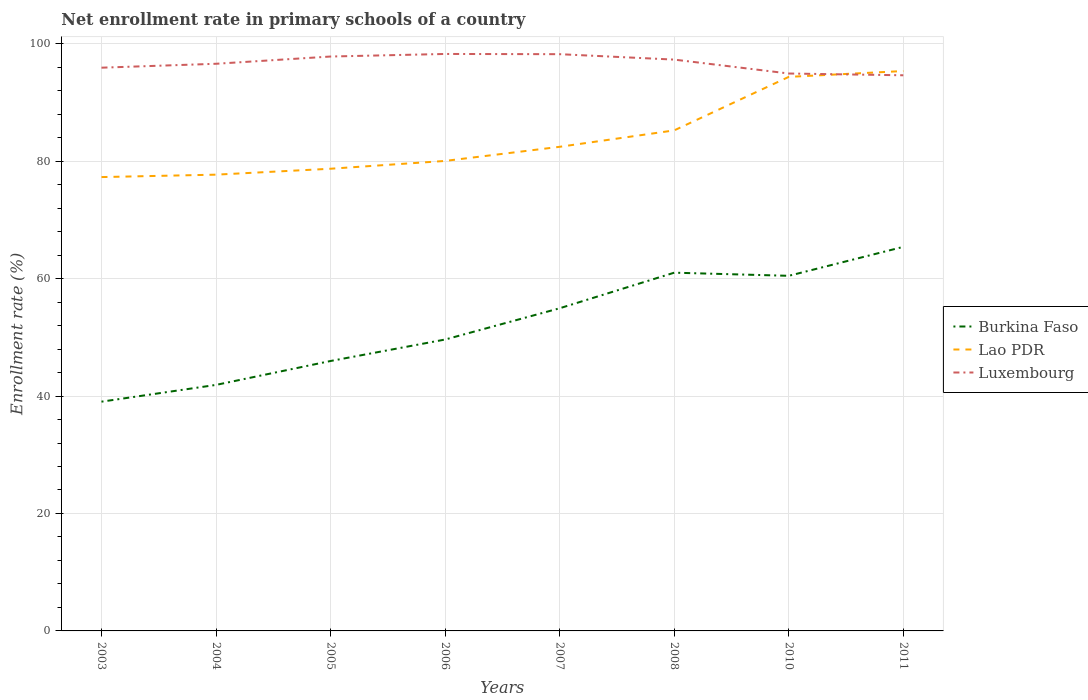Is the number of lines equal to the number of legend labels?
Your answer should be very brief. Yes. Across all years, what is the maximum enrollment rate in primary schools in Lao PDR?
Your answer should be very brief. 77.29. In which year was the enrollment rate in primary schools in Luxembourg maximum?
Offer a very short reply. 2011. What is the total enrollment rate in primary schools in Burkina Faso in the graph?
Your response must be concise. -18.58. What is the difference between the highest and the second highest enrollment rate in primary schools in Luxembourg?
Provide a succinct answer. 3.63. What is the difference between two consecutive major ticks on the Y-axis?
Offer a terse response. 20. Are the values on the major ticks of Y-axis written in scientific E-notation?
Offer a very short reply. No. Does the graph contain grids?
Offer a terse response. Yes. How are the legend labels stacked?
Your answer should be compact. Vertical. What is the title of the graph?
Make the answer very short. Net enrollment rate in primary schools of a country. Does "Macedonia" appear as one of the legend labels in the graph?
Your answer should be very brief. No. What is the label or title of the Y-axis?
Your answer should be compact. Enrollment rate (%). What is the Enrollment rate (%) in Burkina Faso in 2003?
Provide a short and direct response. 39.04. What is the Enrollment rate (%) in Lao PDR in 2003?
Keep it short and to the point. 77.29. What is the Enrollment rate (%) of Luxembourg in 2003?
Make the answer very short. 95.91. What is the Enrollment rate (%) of Burkina Faso in 2004?
Provide a succinct answer. 41.9. What is the Enrollment rate (%) of Lao PDR in 2004?
Offer a very short reply. 77.7. What is the Enrollment rate (%) of Luxembourg in 2004?
Ensure brevity in your answer.  96.58. What is the Enrollment rate (%) of Burkina Faso in 2005?
Offer a terse response. 45.97. What is the Enrollment rate (%) in Lao PDR in 2005?
Give a very brief answer. 78.71. What is the Enrollment rate (%) in Luxembourg in 2005?
Make the answer very short. 97.82. What is the Enrollment rate (%) in Burkina Faso in 2006?
Ensure brevity in your answer.  49.62. What is the Enrollment rate (%) in Lao PDR in 2006?
Make the answer very short. 80.04. What is the Enrollment rate (%) in Luxembourg in 2006?
Provide a succinct answer. 98.25. What is the Enrollment rate (%) in Burkina Faso in 2007?
Keep it short and to the point. 54.95. What is the Enrollment rate (%) in Lao PDR in 2007?
Keep it short and to the point. 82.44. What is the Enrollment rate (%) in Luxembourg in 2007?
Your response must be concise. 98.21. What is the Enrollment rate (%) in Burkina Faso in 2008?
Give a very brief answer. 61.01. What is the Enrollment rate (%) of Lao PDR in 2008?
Provide a short and direct response. 85.24. What is the Enrollment rate (%) of Luxembourg in 2008?
Give a very brief answer. 97.29. What is the Enrollment rate (%) in Burkina Faso in 2010?
Provide a short and direct response. 60.47. What is the Enrollment rate (%) of Lao PDR in 2010?
Your answer should be compact. 94.35. What is the Enrollment rate (%) in Luxembourg in 2010?
Ensure brevity in your answer.  94.92. What is the Enrollment rate (%) in Burkina Faso in 2011?
Your answer should be very brief. 65.4. What is the Enrollment rate (%) of Lao PDR in 2011?
Your answer should be very brief. 95.35. What is the Enrollment rate (%) in Luxembourg in 2011?
Keep it short and to the point. 94.62. Across all years, what is the maximum Enrollment rate (%) of Burkina Faso?
Offer a terse response. 65.4. Across all years, what is the maximum Enrollment rate (%) of Lao PDR?
Offer a very short reply. 95.35. Across all years, what is the maximum Enrollment rate (%) in Luxembourg?
Your answer should be very brief. 98.25. Across all years, what is the minimum Enrollment rate (%) in Burkina Faso?
Offer a very short reply. 39.04. Across all years, what is the minimum Enrollment rate (%) of Lao PDR?
Your answer should be very brief. 77.29. Across all years, what is the minimum Enrollment rate (%) of Luxembourg?
Offer a very short reply. 94.62. What is the total Enrollment rate (%) in Burkina Faso in the graph?
Make the answer very short. 418.36. What is the total Enrollment rate (%) of Lao PDR in the graph?
Your answer should be very brief. 671.11. What is the total Enrollment rate (%) in Luxembourg in the graph?
Your answer should be compact. 773.62. What is the difference between the Enrollment rate (%) in Burkina Faso in 2003 and that in 2004?
Provide a succinct answer. -2.86. What is the difference between the Enrollment rate (%) of Lao PDR in 2003 and that in 2004?
Keep it short and to the point. -0.41. What is the difference between the Enrollment rate (%) of Luxembourg in 2003 and that in 2004?
Make the answer very short. -0.67. What is the difference between the Enrollment rate (%) in Burkina Faso in 2003 and that in 2005?
Make the answer very short. -6.93. What is the difference between the Enrollment rate (%) of Lao PDR in 2003 and that in 2005?
Your answer should be compact. -1.42. What is the difference between the Enrollment rate (%) of Luxembourg in 2003 and that in 2005?
Provide a short and direct response. -1.9. What is the difference between the Enrollment rate (%) in Burkina Faso in 2003 and that in 2006?
Keep it short and to the point. -10.58. What is the difference between the Enrollment rate (%) in Lao PDR in 2003 and that in 2006?
Offer a very short reply. -2.75. What is the difference between the Enrollment rate (%) of Luxembourg in 2003 and that in 2006?
Keep it short and to the point. -2.34. What is the difference between the Enrollment rate (%) in Burkina Faso in 2003 and that in 2007?
Offer a very short reply. -15.91. What is the difference between the Enrollment rate (%) of Lao PDR in 2003 and that in 2007?
Ensure brevity in your answer.  -5.16. What is the difference between the Enrollment rate (%) of Luxembourg in 2003 and that in 2007?
Your answer should be compact. -2.3. What is the difference between the Enrollment rate (%) in Burkina Faso in 2003 and that in 2008?
Offer a terse response. -21.96. What is the difference between the Enrollment rate (%) in Lao PDR in 2003 and that in 2008?
Provide a short and direct response. -7.95. What is the difference between the Enrollment rate (%) of Luxembourg in 2003 and that in 2008?
Your answer should be very brief. -1.38. What is the difference between the Enrollment rate (%) of Burkina Faso in 2003 and that in 2010?
Offer a very short reply. -21.43. What is the difference between the Enrollment rate (%) in Lao PDR in 2003 and that in 2010?
Your answer should be very brief. -17.06. What is the difference between the Enrollment rate (%) of Luxembourg in 2003 and that in 2010?
Offer a terse response. 0.99. What is the difference between the Enrollment rate (%) of Burkina Faso in 2003 and that in 2011?
Offer a terse response. -26.36. What is the difference between the Enrollment rate (%) of Lao PDR in 2003 and that in 2011?
Offer a very short reply. -18.06. What is the difference between the Enrollment rate (%) in Luxembourg in 2003 and that in 2011?
Your answer should be very brief. 1.29. What is the difference between the Enrollment rate (%) in Burkina Faso in 2004 and that in 2005?
Provide a succinct answer. -4.07. What is the difference between the Enrollment rate (%) of Lao PDR in 2004 and that in 2005?
Offer a very short reply. -1.01. What is the difference between the Enrollment rate (%) in Luxembourg in 2004 and that in 2005?
Keep it short and to the point. -1.23. What is the difference between the Enrollment rate (%) of Burkina Faso in 2004 and that in 2006?
Make the answer very short. -7.73. What is the difference between the Enrollment rate (%) of Lao PDR in 2004 and that in 2006?
Ensure brevity in your answer.  -2.34. What is the difference between the Enrollment rate (%) in Luxembourg in 2004 and that in 2006?
Give a very brief answer. -1.67. What is the difference between the Enrollment rate (%) in Burkina Faso in 2004 and that in 2007?
Offer a terse response. -13.05. What is the difference between the Enrollment rate (%) in Lao PDR in 2004 and that in 2007?
Provide a short and direct response. -4.74. What is the difference between the Enrollment rate (%) in Luxembourg in 2004 and that in 2007?
Ensure brevity in your answer.  -1.63. What is the difference between the Enrollment rate (%) of Burkina Faso in 2004 and that in 2008?
Provide a short and direct response. -19.11. What is the difference between the Enrollment rate (%) in Lao PDR in 2004 and that in 2008?
Keep it short and to the point. -7.54. What is the difference between the Enrollment rate (%) of Luxembourg in 2004 and that in 2008?
Offer a terse response. -0.71. What is the difference between the Enrollment rate (%) of Burkina Faso in 2004 and that in 2010?
Offer a very short reply. -18.58. What is the difference between the Enrollment rate (%) of Lao PDR in 2004 and that in 2010?
Offer a terse response. -16.65. What is the difference between the Enrollment rate (%) of Luxembourg in 2004 and that in 2010?
Keep it short and to the point. 1.66. What is the difference between the Enrollment rate (%) of Burkina Faso in 2004 and that in 2011?
Your response must be concise. -23.51. What is the difference between the Enrollment rate (%) in Lao PDR in 2004 and that in 2011?
Keep it short and to the point. -17.65. What is the difference between the Enrollment rate (%) in Luxembourg in 2004 and that in 2011?
Give a very brief answer. 1.96. What is the difference between the Enrollment rate (%) of Burkina Faso in 2005 and that in 2006?
Offer a terse response. -3.66. What is the difference between the Enrollment rate (%) in Lao PDR in 2005 and that in 2006?
Give a very brief answer. -1.33. What is the difference between the Enrollment rate (%) of Luxembourg in 2005 and that in 2006?
Keep it short and to the point. -0.44. What is the difference between the Enrollment rate (%) of Burkina Faso in 2005 and that in 2007?
Give a very brief answer. -8.98. What is the difference between the Enrollment rate (%) of Lao PDR in 2005 and that in 2007?
Offer a terse response. -3.73. What is the difference between the Enrollment rate (%) in Luxembourg in 2005 and that in 2007?
Provide a succinct answer. -0.4. What is the difference between the Enrollment rate (%) in Burkina Faso in 2005 and that in 2008?
Provide a short and direct response. -15.04. What is the difference between the Enrollment rate (%) of Lao PDR in 2005 and that in 2008?
Give a very brief answer. -6.53. What is the difference between the Enrollment rate (%) of Luxembourg in 2005 and that in 2008?
Give a very brief answer. 0.52. What is the difference between the Enrollment rate (%) of Burkina Faso in 2005 and that in 2010?
Your answer should be very brief. -14.51. What is the difference between the Enrollment rate (%) of Lao PDR in 2005 and that in 2010?
Offer a very short reply. -15.64. What is the difference between the Enrollment rate (%) of Luxembourg in 2005 and that in 2010?
Keep it short and to the point. 2.89. What is the difference between the Enrollment rate (%) of Burkina Faso in 2005 and that in 2011?
Your response must be concise. -19.44. What is the difference between the Enrollment rate (%) of Lao PDR in 2005 and that in 2011?
Your response must be concise. -16.64. What is the difference between the Enrollment rate (%) of Luxembourg in 2005 and that in 2011?
Make the answer very short. 3.19. What is the difference between the Enrollment rate (%) of Burkina Faso in 2006 and that in 2007?
Ensure brevity in your answer.  -5.32. What is the difference between the Enrollment rate (%) in Lao PDR in 2006 and that in 2007?
Ensure brevity in your answer.  -2.4. What is the difference between the Enrollment rate (%) in Luxembourg in 2006 and that in 2007?
Provide a succinct answer. 0.04. What is the difference between the Enrollment rate (%) of Burkina Faso in 2006 and that in 2008?
Offer a very short reply. -11.38. What is the difference between the Enrollment rate (%) of Lao PDR in 2006 and that in 2008?
Provide a short and direct response. -5.2. What is the difference between the Enrollment rate (%) in Luxembourg in 2006 and that in 2008?
Your answer should be compact. 0.96. What is the difference between the Enrollment rate (%) in Burkina Faso in 2006 and that in 2010?
Offer a very short reply. -10.85. What is the difference between the Enrollment rate (%) of Lao PDR in 2006 and that in 2010?
Provide a short and direct response. -14.31. What is the difference between the Enrollment rate (%) of Luxembourg in 2006 and that in 2010?
Provide a succinct answer. 3.33. What is the difference between the Enrollment rate (%) in Burkina Faso in 2006 and that in 2011?
Your response must be concise. -15.78. What is the difference between the Enrollment rate (%) in Lao PDR in 2006 and that in 2011?
Provide a short and direct response. -15.31. What is the difference between the Enrollment rate (%) of Luxembourg in 2006 and that in 2011?
Offer a terse response. 3.63. What is the difference between the Enrollment rate (%) of Burkina Faso in 2007 and that in 2008?
Your response must be concise. -6.06. What is the difference between the Enrollment rate (%) of Lao PDR in 2007 and that in 2008?
Provide a short and direct response. -2.8. What is the difference between the Enrollment rate (%) of Luxembourg in 2007 and that in 2008?
Your response must be concise. 0.92. What is the difference between the Enrollment rate (%) in Burkina Faso in 2007 and that in 2010?
Give a very brief answer. -5.53. What is the difference between the Enrollment rate (%) of Lao PDR in 2007 and that in 2010?
Make the answer very short. -11.91. What is the difference between the Enrollment rate (%) in Luxembourg in 2007 and that in 2010?
Provide a short and direct response. 3.29. What is the difference between the Enrollment rate (%) in Burkina Faso in 2007 and that in 2011?
Keep it short and to the point. -10.46. What is the difference between the Enrollment rate (%) of Lao PDR in 2007 and that in 2011?
Your answer should be very brief. -12.9. What is the difference between the Enrollment rate (%) in Luxembourg in 2007 and that in 2011?
Provide a succinct answer. 3.59. What is the difference between the Enrollment rate (%) in Burkina Faso in 2008 and that in 2010?
Your answer should be compact. 0.53. What is the difference between the Enrollment rate (%) in Lao PDR in 2008 and that in 2010?
Your answer should be compact. -9.11. What is the difference between the Enrollment rate (%) in Luxembourg in 2008 and that in 2010?
Keep it short and to the point. 2.37. What is the difference between the Enrollment rate (%) in Burkina Faso in 2008 and that in 2011?
Make the answer very short. -4.4. What is the difference between the Enrollment rate (%) of Lao PDR in 2008 and that in 2011?
Your response must be concise. -10.11. What is the difference between the Enrollment rate (%) of Luxembourg in 2008 and that in 2011?
Your answer should be compact. 2.67. What is the difference between the Enrollment rate (%) in Burkina Faso in 2010 and that in 2011?
Make the answer very short. -4.93. What is the difference between the Enrollment rate (%) of Lao PDR in 2010 and that in 2011?
Offer a terse response. -1. What is the difference between the Enrollment rate (%) of Luxembourg in 2010 and that in 2011?
Your answer should be very brief. 0.3. What is the difference between the Enrollment rate (%) in Burkina Faso in 2003 and the Enrollment rate (%) in Lao PDR in 2004?
Provide a short and direct response. -38.66. What is the difference between the Enrollment rate (%) of Burkina Faso in 2003 and the Enrollment rate (%) of Luxembourg in 2004?
Give a very brief answer. -57.54. What is the difference between the Enrollment rate (%) of Lao PDR in 2003 and the Enrollment rate (%) of Luxembourg in 2004?
Your answer should be compact. -19.3. What is the difference between the Enrollment rate (%) in Burkina Faso in 2003 and the Enrollment rate (%) in Lao PDR in 2005?
Keep it short and to the point. -39.67. What is the difference between the Enrollment rate (%) in Burkina Faso in 2003 and the Enrollment rate (%) in Luxembourg in 2005?
Provide a succinct answer. -58.78. What is the difference between the Enrollment rate (%) in Lao PDR in 2003 and the Enrollment rate (%) in Luxembourg in 2005?
Provide a succinct answer. -20.53. What is the difference between the Enrollment rate (%) of Burkina Faso in 2003 and the Enrollment rate (%) of Lao PDR in 2006?
Keep it short and to the point. -41. What is the difference between the Enrollment rate (%) in Burkina Faso in 2003 and the Enrollment rate (%) in Luxembourg in 2006?
Keep it short and to the point. -59.21. What is the difference between the Enrollment rate (%) of Lao PDR in 2003 and the Enrollment rate (%) of Luxembourg in 2006?
Your response must be concise. -20.97. What is the difference between the Enrollment rate (%) in Burkina Faso in 2003 and the Enrollment rate (%) in Lao PDR in 2007?
Your answer should be very brief. -43.4. What is the difference between the Enrollment rate (%) in Burkina Faso in 2003 and the Enrollment rate (%) in Luxembourg in 2007?
Provide a short and direct response. -59.17. What is the difference between the Enrollment rate (%) in Lao PDR in 2003 and the Enrollment rate (%) in Luxembourg in 2007?
Provide a succinct answer. -20.93. What is the difference between the Enrollment rate (%) in Burkina Faso in 2003 and the Enrollment rate (%) in Lao PDR in 2008?
Make the answer very short. -46.2. What is the difference between the Enrollment rate (%) in Burkina Faso in 2003 and the Enrollment rate (%) in Luxembourg in 2008?
Provide a succinct answer. -58.25. What is the difference between the Enrollment rate (%) in Lao PDR in 2003 and the Enrollment rate (%) in Luxembourg in 2008?
Offer a very short reply. -20.01. What is the difference between the Enrollment rate (%) of Burkina Faso in 2003 and the Enrollment rate (%) of Lao PDR in 2010?
Provide a succinct answer. -55.31. What is the difference between the Enrollment rate (%) in Burkina Faso in 2003 and the Enrollment rate (%) in Luxembourg in 2010?
Offer a very short reply. -55.88. What is the difference between the Enrollment rate (%) of Lao PDR in 2003 and the Enrollment rate (%) of Luxembourg in 2010?
Your answer should be compact. -17.64. What is the difference between the Enrollment rate (%) of Burkina Faso in 2003 and the Enrollment rate (%) of Lao PDR in 2011?
Offer a very short reply. -56.3. What is the difference between the Enrollment rate (%) of Burkina Faso in 2003 and the Enrollment rate (%) of Luxembourg in 2011?
Offer a terse response. -55.58. What is the difference between the Enrollment rate (%) in Lao PDR in 2003 and the Enrollment rate (%) in Luxembourg in 2011?
Your answer should be very brief. -17.34. What is the difference between the Enrollment rate (%) of Burkina Faso in 2004 and the Enrollment rate (%) of Lao PDR in 2005?
Your response must be concise. -36.81. What is the difference between the Enrollment rate (%) in Burkina Faso in 2004 and the Enrollment rate (%) in Luxembourg in 2005?
Your answer should be compact. -55.92. What is the difference between the Enrollment rate (%) in Lao PDR in 2004 and the Enrollment rate (%) in Luxembourg in 2005?
Your answer should be very brief. -20.12. What is the difference between the Enrollment rate (%) of Burkina Faso in 2004 and the Enrollment rate (%) of Lao PDR in 2006?
Offer a very short reply. -38.14. What is the difference between the Enrollment rate (%) of Burkina Faso in 2004 and the Enrollment rate (%) of Luxembourg in 2006?
Your answer should be very brief. -56.36. What is the difference between the Enrollment rate (%) in Lao PDR in 2004 and the Enrollment rate (%) in Luxembourg in 2006?
Provide a short and direct response. -20.55. What is the difference between the Enrollment rate (%) of Burkina Faso in 2004 and the Enrollment rate (%) of Lao PDR in 2007?
Give a very brief answer. -40.55. What is the difference between the Enrollment rate (%) in Burkina Faso in 2004 and the Enrollment rate (%) in Luxembourg in 2007?
Offer a terse response. -56.32. What is the difference between the Enrollment rate (%) in Lao PDR in 2004 and the Enrollment rate (%) in Luxembourg in 2007?
Give a very brief answer. -20.52. What is the difference between the Enrollment rate (%) of Burkina Faso in 2004 and the Enrollment rate (%) of Lao PDR in 2008?
Ensure brevity in your answer.  -43.34. What is the difference between the Enrollment rate (%) in Burkina Faso in 2004 and the Enrollment rate (%) in Luxembourg in 2008?
Your response must be concise. -55.4. What is the difference between the Enrollment rate (%) in Lao PDR in 2004 and the Enrollment rate (%) in Luxembourg in 2008?
Make the answer very short. -19.59. What is the difference between the Enrollment rate (%) in Burkina Faso in 2004 and the Enrollment rate (%) in Lao PDR in 2010?
Provide a short and direct response. -52.45. What is the difference between the Enrollment rate (%) in Burkina Faso in 2004 and the Enrollment rate (%) in Luxembourg in 2010?
Offer a very short reply. -53.03. What is the difference between the Enrollment rate (%) of Lao PDR in 2004 and the Enrollment rate (%) of Luxembourg in 2010?
Offer a terse response. -17.22. What is the difference between the Enrollment rate (%) of Burkina Faso in 2004 and the Enrollment rate (%) of Lao PDR in 2011?
Provide a short and direct response. -53.45. What is the difference between the Enrollment rate (%) in Burkina Faso in 2004 and the Enrollment rate (%) in Luxembourg in 2011?
Provide a short and direct response. -52.73. What is the difference between the Enrollment rate (%) in Lao PDR in 2004 and the Enrollment rate (%) in Luxembourg in 2011?
Provide a short and direct response. -16.92. What is the difference between the Enrollment rate (%) of Burkina Faso in 2005 and the Enrollment rate (%) of Lao PDR in 2006?
Your answer should be compact. -34.07. What is the difference between the Enrollment rate (%) in Burkina Faso in 2005 and the Enrollment rate (%) in Luxembourg in 2006?
Keep it short and to the point. -52.29. What is the difference between the Enrollment rate (%) in Lao PDR in 2005 and the Enrollment rate (%) in Luxembourg in 2006?
Your answer should be compact. -19.55. What is the difference between the Enrollment rate (%) of Burkina Faso in 2005 and the Enrollment rate (%) of Lao PDR in 2007?
Provide a short and direct response. -36.47. What is the difference between the Enrollment rate (%) in Burkina Faso in 2005 and the Enrollment rate (%) in Luxembourg in 2007?
Your answer should be compact. -52.25. What is the difference between the Enrollment rate (%) of Lao PDR in 2005 and the Enrollment rate (%) of Luxembourg in 2007?
Ensure brevity in your answer.  -19.51. What is the difference between the Enrollment rate (%) of Burkina Faso in 2005 and the Enrollment rate (%) of Lao PDR in 2008?
Your response must be concise. -39.27. What is the difference between the Enrollment rate (%) of Burkina Faso in 2005 and the Enrollment rate (%) of Luxembourg in 2008?
Your response must be concise. -51.33. What is the difference between the Enrollment rate (%) in Lao PDR in 2005 and the Enrollment rate (%) in Luxembourg in 2008?
Ensure brevity in your answer.  -18.59. What is the difference between the Enrollment rate (%) in Burkina Faso in 2005 and the Enrollment rate (%) in Lao PDR in 2010?
Make the answer very short. -48.38. What is the difference between the Enrollment rate (%) of Burkina Faso in 2005 and the Enrollment rate (%) of Luxembourg in 2010?
Keep it short and to the point. -48.96. What is the difference between the Enrollment rate (%) of Lao PDR in 2005 and the Enrollment rate (%) of Luxembourg in 2010?
Provide a short and direct response. -16.22. What is the difference between the Enrollment rate (%) of Burkina Faso in 2005 and the Enrollment rate (%) of Lao PDR in 2011?
Keep it short and to the point. -49.38. What is the difference between the Enrollment rate (%) in Burkina Faso in 2005 and the Enrollment rate (%) in Luxembourg in 2011?
Ensure brevity in your answer.  -48.65. What is the difference between the Enrollment rate (%) in Lao PDR in 2005 and the Enrollment rate (%) in Luxembourg in 2011?
Give a very brief answer. -15.91. What is the difference between the Enrollment rate (%) in Burkina Faso in 2006 and the Enrollment rate (%) in Lao PDR in 2007?
Your answer should be very brief. -32.82. What is the difference between the Enrollment rate (%) of Burkina Faso in 2006 and the Enrollment rate (%) of Luxembourg in 2007?
Offer a terse response. -48.59. What is the difference between the Enrollment rate (%) of Lao PDR in 2006 and the Enrollment rate (%) of Luxembourg in 2007?
Offer a very short reply. -18.18. What is the difference between the Enrollment rate (%) in Burkina Faso in 2006 and the Enrollment rate (%) in Lao PDR in 2008?
Offer a terse response. -35.62. What is the difference between the Enrollment rate (%) in Burkina Faso in 2006 and the Enrollment rate (%) in Luxembourg in 2008?
Provide a short and direct response. -47.67. What is the difference between the Enrollment rate (%) of Lao PDR in 2006 and the Enrollment rate (%) of Luxembourg in 2008?
Give a very brief answer. -17.26. What is the difference between the Enrollment rate (%) of Burkina Faso in 2006 and the Enrollment rate (%) of Lao PDR in 2010?
Make the answer very short. -44.73. What is the difference between the Enrollment rate (%) of Burkina Faso in 2006 and the Enrollment rate (%) of Luxembourg in 2010?
Your answer should be compact. -45.3. What is the difference between the Enrollment rate (%) of Lao PDR in 2006 and the Enrollment rate (%) of Luxembourg in 2010?
Your answer should be very brief. -14.89. What is the difference between the Enrollment rate (%) of Burkina Faso in 2006 and the Enrollment rate (%) of Lao PDR in 2011?
Keep it short and to the point. -45.72. What is the difference between the Enrollment rate (%) in Burkina Faso in 2006 and the Enrollment rate (%) in Luxembourg in 2011?
Offer a very short reply. -45. What is the difference between the Enrollment rate (%) in Lao PDR in 2006 and the Enrollment rate (%) in Luxembourg in 2011?
Ensure brevity in your answer.  -14.58. What is the difference between the Enrollment rate (%) in Burkina Faso in 2007 and the Enrollment rate (%) in Lao PDR in 2008?
Keep it short and to the point. -30.29. What is the difference between the Enrollment rate (%) in Burkina Faso in 2007 and the Enrollment rate (%) in Luxembourg in 2008?
Offer a terse response. -42.35. What is the difference between the Enrollment rate (%) in Lao PDR in 2007 and the Enrollment rate (%) in Luxembourg in 2008?
Your response must be concise. -14.85. What is the difference between the Enrollment rate (%) in Burkina Faso in 2007 and the Enrollment rate (%) in Lao PDR in 2010?
Offer a very short reply. -39.4. What is the difference between the Enrollment rate (%) in Burkina Faso in 2007 and the Enrollment rate (%) in Luxembourg in 2010?
Give a very brief answer. -39.98. What is the difference between the Enrollment rate (%) of Lao PDR in 2007 and the Enrollment rate (%) of Luxembourg in 2010?
Keep it short and to the point. -12.48. What is the difference between the Enrollment rate (%) of Burkina Faso in 2007 and the Enrollment rate (%) of Lao PDR in 2011?
Your response must be concise. -40.4. What is the difference between the Enrollment rate (%) of Burkina Faso in 2007 and the Enrollment rate (%) of Luxembourg in 2011?
Your answer should be compact. -39.68. What is the difference between the Enrollment rate (%) in Lao PDR in 2007 and the Enrollment rate (%) in Luxembourg in 2011?
Your answer should be compact. -12.18. What is the difference between the Enrollment rate (%) of Burkina Faso in 2008 and the Enrollment rate (%) of Lao PDR in 2010?
Your answer should be compact. -33.34. What is the difference between the Enrollment rate (%) in Burkina Faso in 2008 and the Enrollment rate (%) in Luxembourg in 2010?
Provide a short and direct response. -33.92. What is the difference between the Enrollment rate (%) in Lao PDR in 2008 and the Enrollment rate (%) in Luxembourg in 2010?
Your answer should be compact. -9.68. What is the difference between the Enrollment rate (%) in Burkina Faso in 2008 and the Enrollment rate (%) in Lao PDR in 2011?
Give a very brief answer. -34.34. What is the difference between the Enrollment rate (%) in Burkina Faso in 2008 and the Enrollment rate (%) in Luxembourg in 2011?
Your response must be concise. -33.62. What is the difference between the Enrollment rate (%) of Lao PDR in 2008 and the Enrollment rate (%) of Luxembourg in 2011?
Offer a very short reply. -9.38. What is the difference between the Enrollment rate (%) in Burkina Faso in 2010 and the Enrollment rate (%) in Lao PDR in 2011?
Make the answer very short. -34.87. What is the difference between the Enrollment rate (%) of Burkina Faso in 2010 and the Enrollment rate (%) of Luxembourg in 2011?
Ensure brevity in your answer.  -34.15. What is the difference between the Enrollment rate (%) of Lao PDR in 2010 and the Enrollment rate (%) of Luxembourg in 2011?
Your response must be concise. -0.27. What is the average Enrollment rate (%) in Burkina Faso per year?
Provide a short and direct response. 52.29. What is the average Enrollment rate (%) in Lao PDR per year?
Make the answer very short. 83.89. What is the average Enrollment rate (%) of Luxembourg per year?
Offer a very short reply. 96.7. In the year 2003, what is the difference between the Enrollment rate (%) in Burkina Faso and Enrollment rate (%) in Lao PDR?
Make the answer very short. -38.24. In the year 2003, what is the difference between the Enrollment rate (%) of Burkina Faso and Enrollment rate (%) of Luxembourg?
Make the answer very short. -56.87. In the year 2003, what is the difference between the Enrollment rate (%) of Lao PDR and Enrollment rate (%) of Luxembourg?
Give a very brief answer. -18.63. In the year 2004, what is the difference between the Enrollment rate (%) in Burkina Faso and Enrollment rate (%) in Lao PDR?
Your answer should be very brief. -35.8. In the year 2004, what is the difference between the Enrollment rate (%) in Burkina Faso and Enrollment rate (%) in Luxembourg?
Ensure brevity in your answer.  -54.69. In the year 2004, what is the difference between the Enrollment rate (%) of Lao PDR and Enrollment rate (%) of Luxembourg?
Your answer should be very brief. -18.88. In the year 2005, what is the difference between the Enrollment rate (%) in Burkina Faso and Enrollment rate (%) in Lao PDR?
Give a very brief answer. -32.74. In the year 2005, what is the difference between the Enrollment rate (%) in Burkina Faso and Enrollment rate (%) in Luxembourg?
Your answer should be compact. -51.85. In the year 2005, what is the difference between the Enrollment rate (%) of Lao PDR and Enrollment rate (%) of Luxembourg?
Your answer should be compact. -19.11. In the year 2006, what is the difference between the Enrollment rate (%) in Burkina Faso and Enrollment rate (%) in Lao PDR?
Make the answer very short. -30.41. In the year 2006, what is the difference between the Enrollment rate (%) in Burkina Faso and Enrollment rate (%) in Luxembourg?
Your answer should be compact. -48.63. In the year 2006, what is the difference between the Enrollment rate (%) in Lao PDR and Enrollment rate (%) in Luxembourg?
Ensure brevity in your answer.  -18.22. In the year 2007, what is the difference between the Enrollment rate (%) in Burkina Faso and Enrollment rate (%) in Lao PDR?
Ensure brevity in your answer.  -27.5. In the year 2007, what is the difference between the Enrollment rate (%) of Burkina Faso and Enrollment rate (%) of Luxembourg?
Your response must be concise. -43.27. In the year 2007, what is the difference between the Enrollment rate (%) in Lao PDR and Enrollment rate (%) in Luxembourg?
Make the answer very short. -15.77. In the year 2008, what is the difference between the Enrollment rate (%) in Burkina Faso and Enrollment rate (%) in Lao PDR?
Your response must be concise. -24.23. In the year 2008, what is the difference between the Enrollment rate (%) in Burkina Faso and Enrollment rate (%) in Luxembourg?
Make the answer very short. -36.29. In the year 2008, what is the difference between the Enrollment rate (%) in Lao PDR and Enrollment rate (%) in Luxembourg?
Provide a short and direct response. -12.05. In the year 2010, what is the difference between the Enrollment rate (%) in Burkina Faso and Enrollment rate (%) in Lao PDR?
Keep it short and to the point. -33.88. In the year 2010, what is the difference between the Enrollment rate (%) of Burkina Faso and Enrollment rate (%) of Luxembourg?
Your answer should be compact. -34.45. In the year 2010, what is the difference between the Enrollment rate (%) of Lao PDR and Enrollment rate (%) of Luxembourg?
Provide a short and direct response. -0.57. In the year 2011, what is the difference between the Enrollment rate (%) of Burkina Faso and Enrollment rate (%) of Lao PDR?
Ensure brevity in your answer.  -29.94. In the year 2011, what is the difference between the Enrollment rate (%) of Burkina Faso and Enrollment rate (%) of Luxembourg?
Provide a short and direct response. -29.22. In the year 2011, what is the difference between the Enrollment rate (%) of Lao PDR and Enrollment rate (%) of Luxembourg?
Ensure brevity in your answer.  0.72. What is the ratio of the Enrollment rate (%) of Burkina Faso in 2003 to that in 2004?
Your answer should be very brief. 0.93. What is the ratio of the Enrollment rate (%) of Burkina Faso in 2003 to that in 2005?
Make the answer very short. 0.85. What is the ratio of the Enrollment rate (%) in Lao PDR in 2003 to that in 2005?
Provide a succinct answer. 0.98. What is the ratio of the Enrollment rate (%) in Luxembourg in 2003 to that in 2005?
Your answer should be compact. 0.98. What is the ratio of the Enrollment rate (%) of Burkina Faso in 2003 to that in 2006?
Your answer should be compact. 0.79. What is the ratio of the Enrollment rate (%) of Lao PDR in 2003 to that in 2006?
Offer a very short reply. 0.97. What is the ratio of the Enrollment rate (%) in Luxembourg in 2003 to that in 2006?
Your response must be concise. 0.98. What is the ratio of the Enrollment rate (%) of Burkina Faso in 2003 to that in 2007?
Provide a succinct answer. 0.71. What is the ratio of the Enrollment rate (%) of Luxembourg in 2003 to that in 2007?
Ensure brevity in your answer.  0.98. What is the ratio of the Enrollment rate (%) in Burkina Faso in 2003 to that in 2008?
Your answer should be compact. 0.64. What is the ratio of the Enrollment rate (%) of Lao PDR in 2003 to that in 2008?
Give a very brief answer. 0.91. What is the ratio of the Enrollment rate (%) of Luxembourg in 2003 to that in 2008?
Keep it short and to the point. 0.99. What is the ratio of the Enrollment rate (%) of Burkina Faso in 2003 to that in 2010?
Offer a very short reply. 0.65. What is the ratio of the Enrollment rate (%) in Lao PDR in 2003 to that in 2010?
Offer a very short reply. 0.82. What is the ratio of the Enrollment rate (%) in Luxembourg in 2003 to that in 2010?
Provide a short and direct response. 1.01. What is the ratio of the Enrollment rate (%) in Burkina Faso in 2003 to that in 2011?
Your response must be concise. 0.6. What is the ratio of the Enrollment rate (%) of Lao PDR in 2003 to that in 2011?
Offer a terse response. 0.81. What is the ratio of the Enrollment rate (%) in Luxembourg in 2003 to that in 2011?
Provide a succinct answer. 1.01. What is the ratio of the Enrollment rate (%) of Burkina Faso in 2004 to that in 2005?
Offer a very short reply. 0.91. What is the ratio of the Enrollment rate (%) in Lao PDR in 2004 to that in 2005?
Your response must be concise. 0.99. What is the ratio of the Enrollment rate (%) of Luxembourg in 2004 to that in 2005?
Give a very brief answer. 0.99. What is the ratio of the Enrollment rate (%) of Burkina Faso in 2004 to that in 2006?
Give a very brief answer. 0.84. What is the ratio of the Enrollment rate (%) of Lao PDR in 2004 to that in 2006?
Provide a succinct answer. 0.97. What is the ratio of the Enrollment rate (%) of Luxembourg in 2004 to that in 2006?
Your answer should be very brief. 0.98. What is the ratio of the Enrollment rate (%) of Burkina Faso in 2004 to that in 2007?
Your answer should be compact. 0.76. What is the ratio of the Enrollment rate (%) in Lao PDR in 2004 to that in 2007?
Ensure brevity in your answer.  0.94. What is the ratio of the Enrollment rate (%) in Luxembourg in 2004 to that in 2007?
Provide a short and direct response. 0.98. What is the ratio of the Enrollment rate (%) in Burkina Faso in 2004 to that in 2008?
Offer a terse response. 0.69. What is the ratio of the Enrollment rate (%) of Lao PDR in 2004 to that in 2008?
Your answer should be very brief. 0.91. What is the ratio of the Enrollment rate (%) in Burkina Faso in 2004 to that in 2010?
Make the answer very short. 0.69. What is the ratio of the Enrollment rate (%) of Lao PDR in 2004 to that in 2010?
Your answer should be very brief. 0.82. What is the ratio of the Enrollment rate (%) in Luxembourg in 2004 to that in 2010?
Your answer should be compact. 1.02. What is the ratio of the Enrollment rate (%) in Burkina Faso in 2004 to that in 2011?
Provide a short and direct response. 0.64. What is the ratio of the Enrollment rate (%) of Lao PDR in 2004 to that in 2011?
Ensure brevity in your answer.  0.81. What is the ratio of the Enrollment rate (%) of Luxembourg in 2004 to that in 2011?
Your answer should be very brief. 1.02. What is the ratio of the Enrollment rate (%) of Burkina Faso in 2005 to that in 2006?
Offer a very short reply. 0.93. What is the ratio of the Enrollment rate (%) in Lao PDR in 2005 to that in 2006?
Your answer should be very brief. 0.98. What is the ratio of the Enrollment rate (%) of Luxembourg in 2005 to that in 2006?
Offer a terse response. 1. What is the ratio of the Enrollment rate (%) of Burkina Faso in 2005 to that in 2007?
Your answer should be compact. 0.84. What is the ratio of the Enrollment rate (%) in Lao PDR in 2005 to that in 2007?
Your answer should be compact. 0.95. What is the ratio of the Enrollment rate (%) of Burkina Faso in 2005 to that in 2008?
Your answer should be compact. 0.75. What is the ratio of the Enrollment rate (%) of Lao PDR in 2005 to that in 2008?
Provide a succinct answer. 0.92. What is the ratio of the Enrollment rate (%) of Luxembourg in 2005 to that in 2008?
Keep it short and to the point. 1.01. What is the ratio of the Enrollment rate (%) in Burkina Faso in 2005 to that in 2010?
Offer a very short reply. 0.76. What is the ratio of the Enrollment rate (%) in Lao PDR in 2005 to that in 2010?
Your answer should be very brief. 0.83. What is the ratio of the Enrollment rate (%) of Luxembourg in 2005 to that in 2010?
Make the answer very short. 1.03. What is the ratio of the Enrollment rate (%) of Burkina Faso in 2005 to that in 2011?
Offer a terse response. 0.7. What is the ratio of the Enrollment rate (%) in Lao PDR in 2005 to that in 2011?
Provide a short and direct response. 0.83. What is the ratio of the Enrollment rate (%) of Luxembourg in 2005 to that in 2011?
Offer a terse response. 1.03. What is the ratio of the Enrollment rate (%) in Burkina Faso in 2006 to that in 2007?
Keep it short and to the point. 0.9. What is the ratio of the Enrollment rate (%) in Lao PDR in 2006 to that in 2007?
Offer a very short reply. 0.97. What is the ratio of the Enrollment rate (%) in Burkina Faso in 2006 to that in 2008?
Your response must be concise. 0.81. What is the ratio of the Enrollment rate (%) of Lao PDR in 2006 to that in 2008?
Keep it short and to the point. 0.94. What is the ratio of the Enrollment rate (%) of Luxembourg in 2006 to that in 2008?
Keep it short and to the point. 1.01. What is the ratio of the Enrollment rate (%) in Burkina Faso in 2006 to that in 2010?
Provide a succinct answer. 0.82. What is the ratio of the Enrollment rate (%) in Lao PDR in 2006 to that in 2010?
Your answer should be very brief. 0.85. What is the ratio of the Enrollment rate (%) of Luxembourg in 2006 to that in 2010?
Make the answer very short. 1.04. What is the ratio of the Enrollment rate (%) of Burkina Faso in 2006 to that in 2011?
Your response must be concise. 0.76. What is the ratio of the Enrollment rate (%) in Lao PDR in 2006 to that in 2011?
Offer a terse response. 0.84. What is the ratio of the Enrollment rate (%) in Luxembourg in 2006 to that in 2011?
Offer a terse response. 1.04. What is the ratio of the Enrollment rate (%) of Burkina Faso in 2007 to that in 2008?
Give a very brief answer. 0.9. What is the ratio of the Enrollment rate (%) in Lao PDR in 2007 to that in 2008?
Provide a short and direct response. 0.97. What is the ratio of the Enrollment rate (%) of Luxembourg in 2007 to that in 2008?
Make the answer very short. 1.01. What is the ratio of the Enrollment rate (%) of Burkina Faso in 2007 to that in 2010?
Your answer should be compact. 0.91. What is the ratio of the Enrollment rate (%) of Lao PDR in 2007 to that in 2010?
Offer a terse response. 0.87. What is the ratio of the Enrollment rate (%) of Luxembourg in 2007 to that in 2010?
Offer a terse response. 1.03. What is the ratio of the Enrollment rate (%) in Burkina Faso in 2007 to that in 2011?
Ensure brevity in your answer.  0.84. What is the ratio of the Enrollment rate (%) in Lao PDR in 2007 to that in 2011?
Your response must be concise. 0.86. What is the ratio of the Enrollment rate (%) of Luxembourg in 2007 to that in 2011?
Make the answer very short. 1.04. What is the ratio of the Enrollment rate (%) of Burkina Faso in 2008 to that in 2010?
Your answer should be compact. 1.01. What is the ratio of the Enrollment rate (%) in Lao PDR in 2008 to that in 2010?
Your answer should be compact. 0.9. What is the ratio of the Enrollment rate (%) in Luxembourg in 2008 to that in 2010?
Give a very brief answer. 1.02. What is the ratio of the Enrollment rate (%) in Burkina Faso in 2008 to that in 2011?
Provide a succinct answer. 0.93. What is the ratio of the Enrollment rate (%) in Lao PDR in 2008 to that in 2011?
Give a very brief answer. 0.89. What is the ratio of the Enrollment rate (%) in Luxembourg in 2008 to that in 2011?
Your answer should be compact. 1.03. What is the ratio of the Enrollment rate (%) in Burkina Faso in 2010 to that in 2011?
Make the answer very short. 0.92. What is the difference between the highest and the second highest Enrollment rate (%) of Burkina Faso?
Provide a succinct answer. 4.4. What is the difference between the highest and the second highest Enrollment rate (%) in Luxembourg?
Keep it short and to the point. 0.04. What is the difference between the highest and the lowest Enrollment rate (%) in Burkina Faso?
Give a very brief answer. 26.36. What is the difference between the highest and the lowest Enrollment rate (%) of Lao PDR?
Ensure brevity in your answer.  18.06. What is the difference between the highest and the lowest Enrollment rate (%) in Luxembourg?
Offer a terse response. 3.63. 